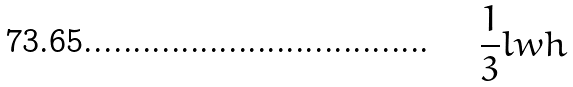Convert formula to latex. <formula><loc_0><loc_0><loc_500><loc_500>\frac { 1 } { 3 } l w h</formula> 